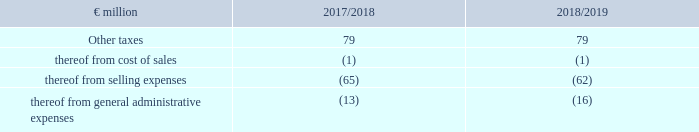18. Other taxes
The other taxes (for example property tax, motor vehicle tax, excise tax and transaction tax) have the following effects on the income statement:
What are examples of taxes under Other taxes? Property tax, motor vehicle tax, excise tax and transaction tax. What was the amount of Other taxes in FY2019?
Answer scale should be: million. 79. What are the costs or expenses under Other taxes in the table? Thereof from cost of sales, thereof from selling expenses, thereof from general administrative expenses. In which year was the amount of other taxes thereof from general administrative expenses larger? |-16|>|-13|
Answer: 2018/2019. What was the change in Other taxes in 2018/2019 from 2017/2018?
Answer scale should be: million. 79-79
Answer: 0. What was the percentage change in Other taxes in 2018/2019 from 2017/2018?
Answer scale should be: percent. (79-79)/79
Answer: 0. 